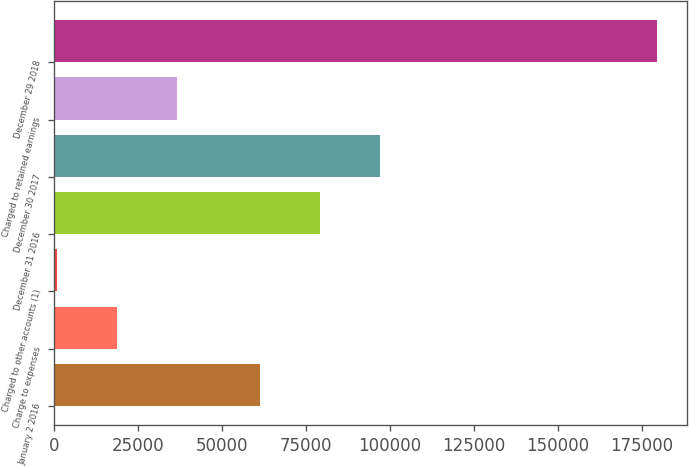Convert chart to OTSL. <chart><loc_0><loc_0><loc_500><loc_500><bar_chart><fcel>January 2 2016<fcel>Charge to expenses<fcel>Charged to other accounts (1)<fcel>December 31 2016<fcel>December 30 2017<fcel>Charged to retained earnings<fcel>December 29 2018<nl><fcel>61358<fcel>18649.3<fcel>766<fcel>79241.3<fcel>97124.6<fcel>36532.6<fcel>179599<nl></chart> 